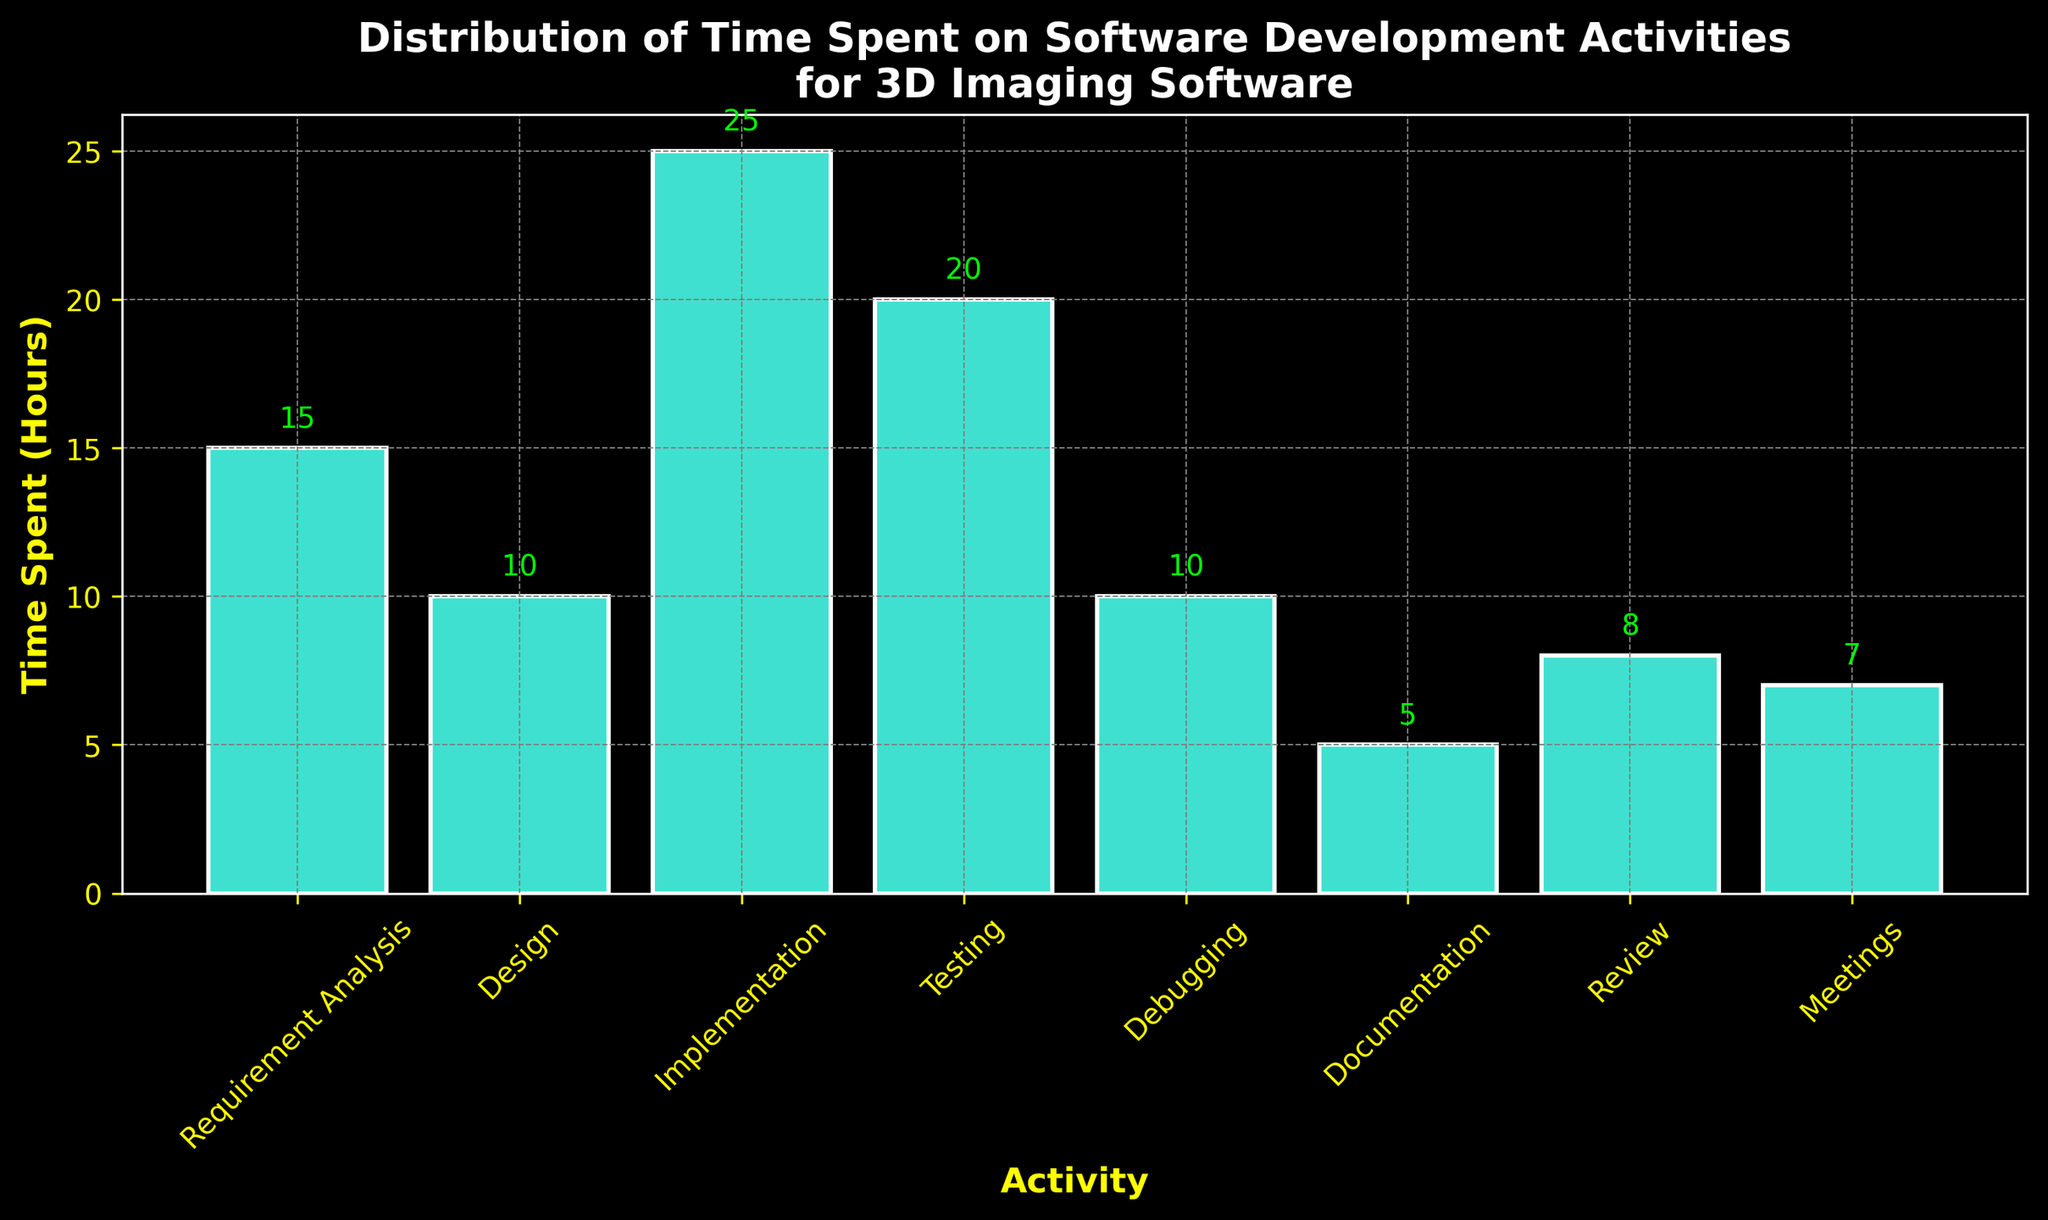What's the activity with the highest time spent? Look for the tallest bar in the chart, which represents the activity with the highest time spent. The tallest bar corresponds to "Implementation" with 25 hours.
Answer: Implementation What is the total time spent on "Debugging" and "Testing"? Identify the bars for "Debugging" and "Testing", then sum their heights. "Debugging" is 10 hours, and "Testing" is 20 hours. 10 + 20 = 30 hours.
Answer: 30 Which activities have the least and most time spent? Locate the shortest and tallest bars in the chart. The shortest bar is "Documentation" with 5 hours, and the tallest bar is "Implementation" with 25 hours.
Answer: Documentation (least), Implementation (most) How much more time is spent on "Testing" than "Design"? Find the heights of the "Testing" and "Design" bars and subtract the shorter height from the taller height. "Testing" is 20 hours, and "Design" is 10 hours. 20 - 10 = 10 hours.
Answer: 10 What is the average time spent on all activities? Add the heights of all bars and divide by the number of bars. (15 + 10 + 25 + 20 + 10 + 5 + 8 + 7) = 100 hours. There are 8 activities, so 100 / 8 = 12.5 hours.
Answer: 12.5 Which activities have more than 15 hours spent on them? Identify bars with heights greater than 15 hours. Only "Implementation" (25 hours) and "Testing" (20 hours) meet this criterion.
Answer: Implementation, Testing What's the difference in time spent between "Requirement Analysis" and "Review"? Calculate the difference in heights between "Requirement Analysis" and "Review" bars. "Requirement Analysis" is 15 hours and "Review" is 8 hours. 15 - 8 = 7 hours.
Answer: 7 Which activities have an equal amount of time spent on them? Look for bars with the same heights. "Design" and "Debugging" both have bars with a height of 10 hours each.
Answer: Design, Debugging What is the combined time spent on "Meetings", "Review", and "Documentation"? Sum the heights of the "Meetings", "Review", and "Documentation" bars. "Meetings" is 7 hours, "Review" is 8 hours, and "Documentation" is 5 hours. 7 + 8 + 5 = 20 hours.
Answer: 20 What percentage of the total time is spent on "Implementation"? First, find the total time spent on all activities (100 hours). "Implementation" is 25 hours. The percentage is (25 / 100) * 100 = 25%.
Answer: 25% 